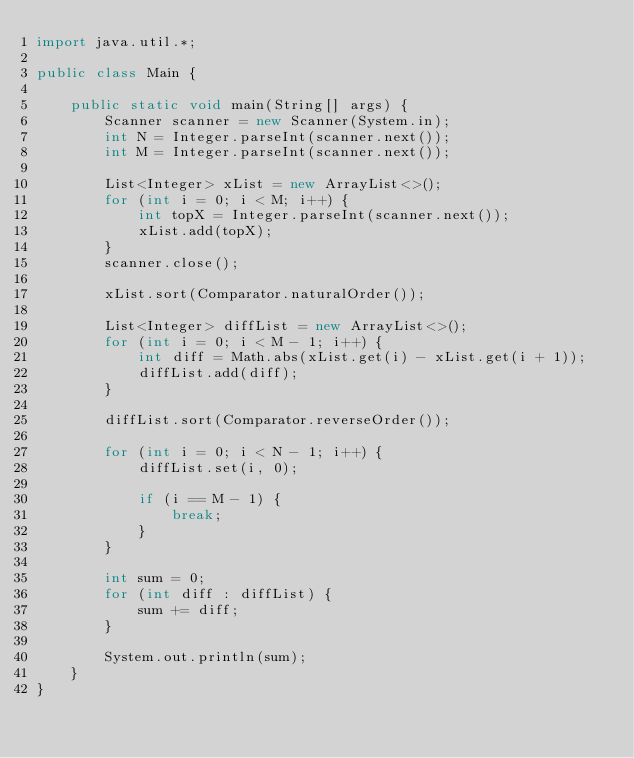<code> <loc_0><loc_0><loc_500><loc_500><_Java_>import java.util.*;

public class Main {

    public static void main(String[] args) {
        Scanner scanner = new Scanner(System.in);
        int N = Integer.parseInt(scanner.next());
        int M = Integer.parseInt(scanner.next());

        List<Integer> xList = new ArrayList<>();
        for (int i = 0; i < M; i++) {
            int topX = Integer.parseInt(scanner.next());
            xList.add(topX);
        }
        scanner.close();

        xList.sort(Comparator.naturalOrder());

        List<Integer> diffList = new ArrayList<>();
        for (int i = 0; i < M - 1; i++) {
            int diff = Math.abs(xList.get(i) - xList.get(i + 1));
            diffList.add(diff);
        }

        diffList.sort(Comparator.reverseOrder());

        for (int i = 0; i < N - 1; i++) {
            diffList.set(i, 0);

            if (i == M - 1) {
                break;
            }
        }

        int sum = 0;
        for (int diff : diffList) {
            sum += diff;
        }

        System.out.println(sum);
    }
}
</code> 